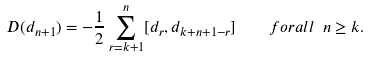<formula> <loc_0><loc_0><loc_500><loc_500>D ( d _ { n + 1 } ) = - \frac { 1 } { 2 } \sum _ { r = k + 1 } ^ { n } [ d _ { r } , d _ { k + n + 1 - r } ] \quad f o r a l l \ n \geq k .</formula> 